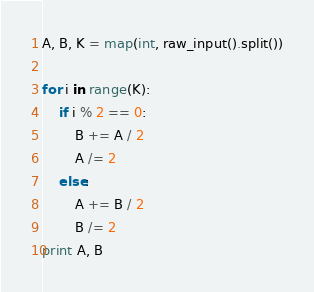Convert code to text. <code><loc_0><loc_0><loc_500><loc_500><_Python_>A, B, K = map(int, raw_input().split())

for i in range(K):
	if i % 2 == 0:
		B += A / 2
		A /= 2
	else:
		A += B / 2
		B /= 2
print A, B
</code> 